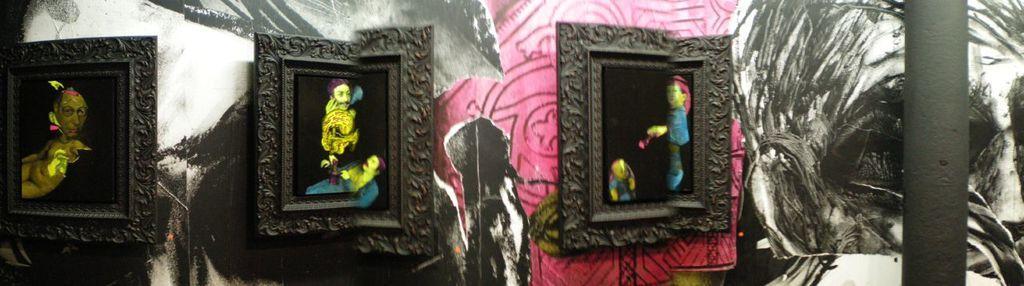How would you summarize this image in a sentence or two? In the center of this picture we can see the picture frames containing pictures of some persons and in the background we can see the pictures of some other objects. On the right corner we can see an object which seems to be the metal rod and this picture seems to be an edited image. 